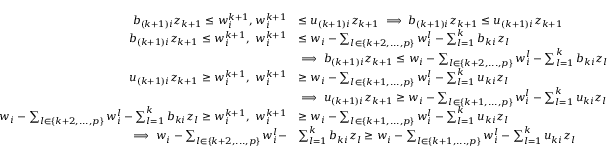Convert formula to latex. <formula><loc_0><loc_0><loc_500><loc_500>\begin{array} { r l } { b _ { ( k + 1 ) i } z _ { k + 1 } \leq w _ { i } ^ { k + 1 } , w _ { i } ^ { k + 1 } } & { \leq u _ { ( k + 1 ) i } z _ { k + 1 } \implies b _ { ( k + 1 ) i } z _ { k + 1 } \leq u _ { ( k + 1 ) i } z _ { k + 1 } } \\ { b _ { ( k + 1 ) i } z _ { k + 1 } \leq w _ { i } ^ { k + 1 } , w _ { i } ^ { k + 1 } } & { \leq w _ { i } - \sum _ { l \in \{ k + 2 , \dots , p \} } w _ { i } ^ { l } - \sum _ { l = 1 } ^ { k } b _ { k i } z _ { l } } \\ & { \implies b _ { ( k + 1 ) i } z _ { k + 1 } \leq w _ { i } - \sum _ { l \in \{ k + 2 , \dots , p \} } w _ { i } ^ { l } - \sum _ { l = 1 } ^ { k } b _ { k i } z _ { l } } \\ { u _ { ( k + 1 ) i } z _ { k + 1 } \geq w _ { i } ^ { k + 1 } , w _ { i } ^ { k + 1 } } & { \geq w _ { i } - \sum _ { l \in \{ k + 1 , \dots , p \} } w _ { i } ^ { l } - \sum _ { l = 1 } ^ { k } u _ { k i } z _ { l } } \\ & { \implies u _ { ( k + 1 ) i } z _ { k + 1 } \geq w _ { i } - \sum _ { l \in \{ k + 1 , \dots , p \} } w _ { i } ^ { l } - \sum _ { l = 1 } ^ { k } u _ { k i } z _ { l } } \\ { w _ { i } - \sum _ { l \in \{ k + 2 , \dots , p \} } w _ { i } ^ { l } - \sum _ { l = 1 } ^ { k } b _ { k i } z _ { l } \geq w _ { i } ^ { k + 1 } , w _ { i } ^ { k + 1 } } & { \geq w _ { i } - \sum _ { l \in \{ k + 1 , \dots , p \} } w _ { i } ^ { l } - \sum _ { l = 1 } ^ { k } u _ { k i } z _ { l } } \\ { \implies w _ { i } - \sum _ { l \in \{ k + 2 , \dots , p \} } w _ { i } ^ { l } - } & { \sum _ { l = 1 } ^ { k } b _ { k i } z _ { l } \geq w _ { i } - \sum _ { l \in \{ k + 1 , \dots , p \} } w _ { i } ^ { l } - \sum _ { l = 1 } ^ { k } u _ { k i } z _ { l } } \end{array}</formula> 